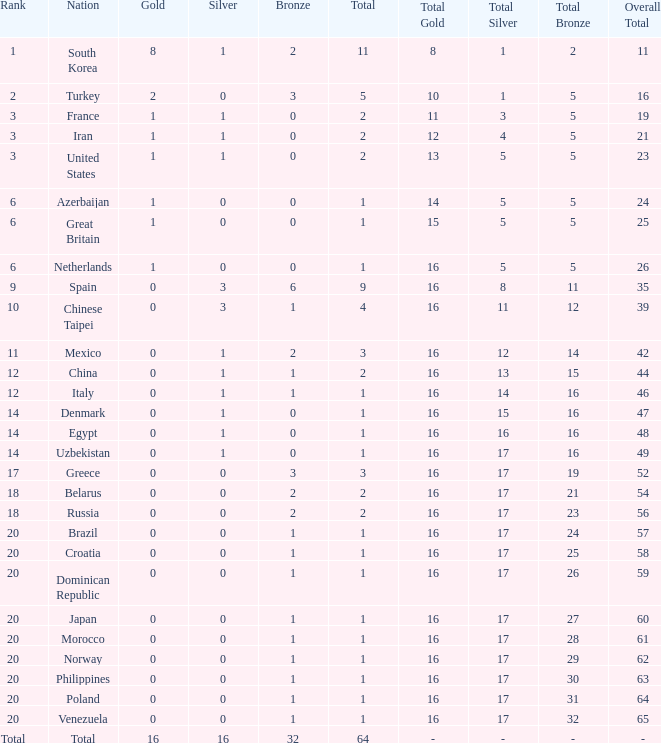What is the average number of bronze of the nation with more than 1 gold and 1 silver medal? 2.0. 